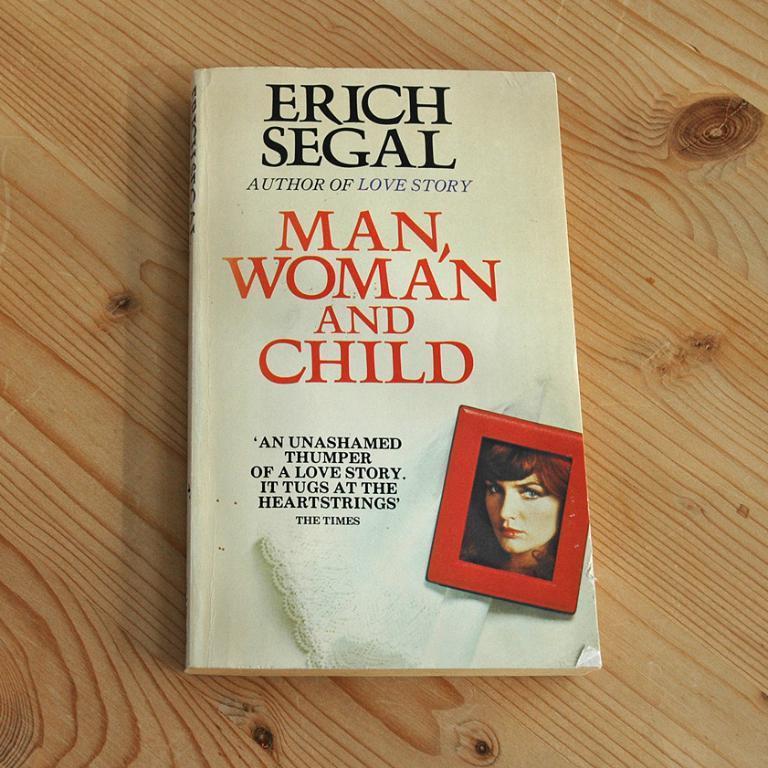Please provide a concise description of this image. Here I can see a book which is placed on a wooden surface. On the book, I can see some text and an image of a person. 